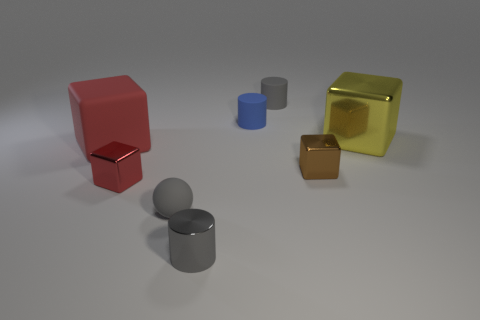Subtract all big red rubber blocks. How many blocks are left? 3 Add 2 tiny matte things. How many objects exist? 10 Subtract all red cylinders. How many red blocks are left? 2 Subtract all yellow cubes. How many cubes are left? 3 Subtract 2 gray cylinders. How many objects are left? 6 Subtract all cylinders. How many objects are left? 5 Subtract 2 blocks. How many blocks are left? 2 Subtract all brown cylinders. Subtract all brown blocks. How many cylinders are left? 3 Subtract all large brown cylinders. Subtract all blue objects. How many objects are left? 7 Add 8 big metal things. How many big metal things are left? 9 